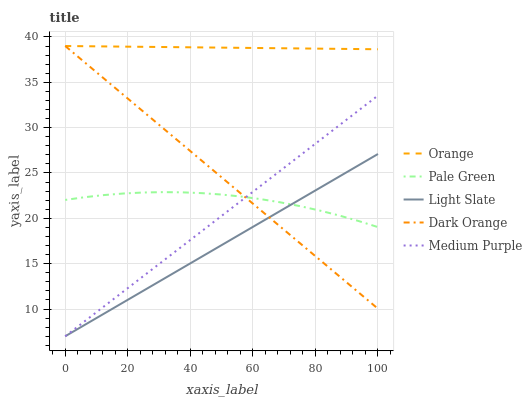Does Light Slate have the minimum area under the curve?
Answer yes or no. Yes. Does Orange have the maximum area under the curve?
Answer yes or no. Yes. Does Medium Purple have the minimum area under the curve?
Answer yes or no. No. Does Medium Purple have the maximum area under the curve?
Answer yes or no. No. Is Medium Purple the smoothest?
Answer yes or no. Yes. Is Pale Green the roughest?
Answer yes or no. Yes. Is Light Slate the smoothest?
Answer yes or no. No. Is Light Slate the roughest?
Answer yes or no. No. Does Light Slate have the lowest value?
Answer yes or no. Yes. Does Pale Green have the lowest value?
Answer yes or no. No. Does Dark Orange have the highest value?
Answer yes or no. Yes. Does Light Slate have the highest value?
Answer yes or no. No. Is Medium Purple less than Orange?
Answer yes or no. Yes. Is Orange greater than Medium Purple?
Answer yes or no. Yes. Does Light Slate intersect Medium Purple?
Answer yes or no. Yes. Is Light Slate less than Medium Purple?
Answer yes or no. No. Is Light Slate greater than Medium Purple?
Answer yes or no. No. Does Medium Purple intersect Orange?
Answer yes or no. No. 